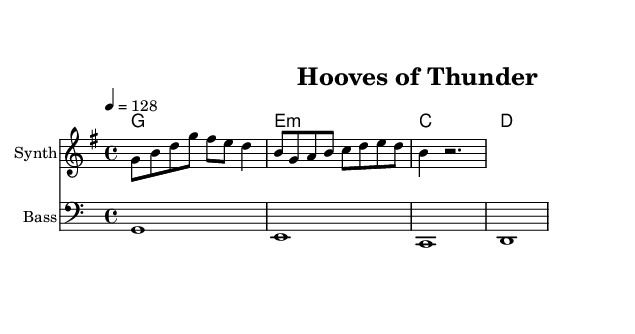What is the key signature of this music? The key signature is G major, which has one sharp (F#).
Answer: G major What is the time signature of the piece? The time signature is 4/4, indicating four beats per measure, with a quarter note receiving one beat.
Answer: 4/4 What is the tempo marking in this score? The tempo marking is 128, which indicates the beats per minute for the performance speed.
Answer: 128 How many measures does the melody contain? The melody consists of three measures, as indicated by the grouping of notes with bar lines.
Answer: 3 What chord accompanies the first measure of the melody? The first measure is accompanied by a G chord, as indicated by the chord name written above the staff.
Answer: G Explain the relationship between the harmony and the melody in the first two measures. In the first two measures, the melody starts with notes from the G major scale, while the harmony supports it with a G chord. The melody's notes (G, B, D) align with the chord tones, creating a harmonious sound.
Answer: They are harmonious What could be inferred about the overall mood of this dance piece? The lively tempo of 128 beats per minute, along with the upbeat melody that uses a major key, suggests a festive and energetic mood appropriate for a dance celebrating horse racing.
Answer: Festive 